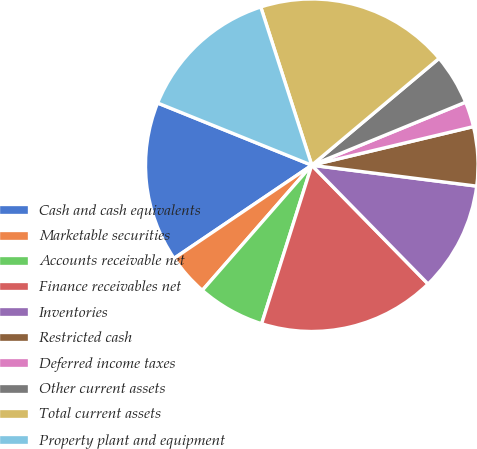Convert chart to OTSL. <chart><loc_0><loc_0><loc_500><loc_500><pie_chart><fcel>Cash and cash equivalents<fcel>Marketable securities<fcel>Accounts receivable net<fcel>Finance receivables net<fcel>Inventories<fcel>Restricted cash<fcel>Deferred income taxes<fcel>Other current assets<fcel>Total current assets<fcel>Property plant and equipment<nl><fcel>15.57%<fcel>4.1%<fcel>6.56%<fcel>17.21%<fcel>10.66%<fcel>5.74%<fcel>2.46%<fcel>4.92%<fcel>18.85%<fcel>13.93%<nl></chart> 